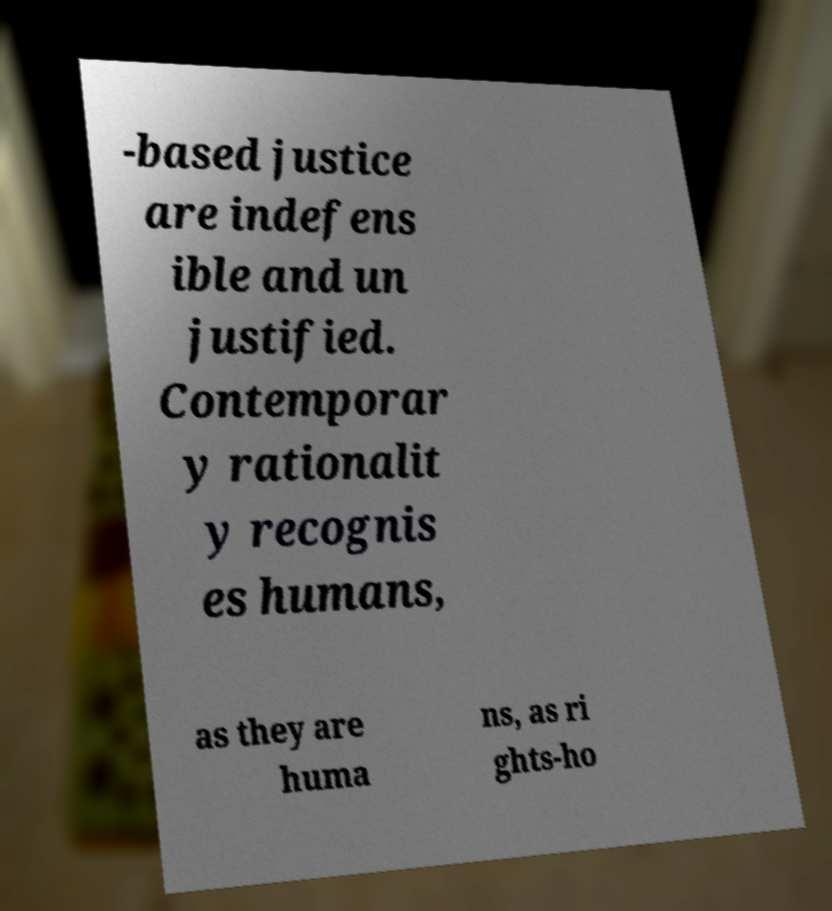There's text embedded in this image that I need extracted. Can you transcribe it verbatim? -based justice are indefens ible and un justified. Contemporar y rationalit y recognis es humans, as they are huma ns, as ri ghts-ho 